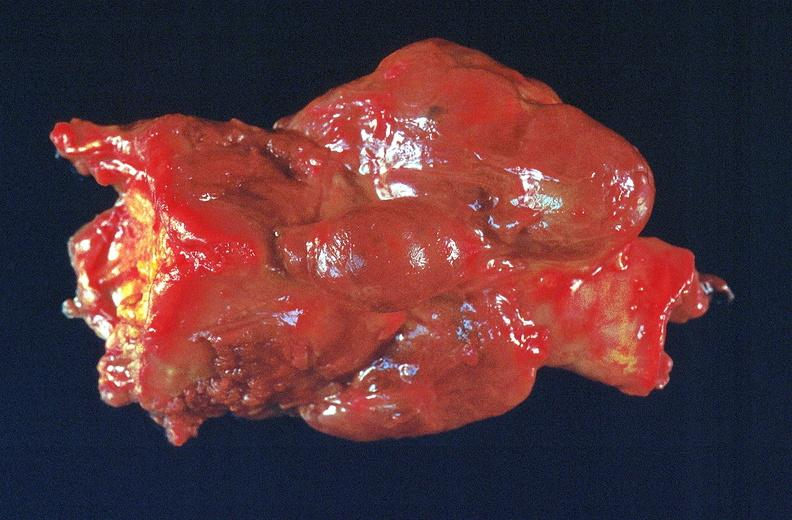does this image show thyroid, goiter?
Answer the question using a single word or phrase. Yes 